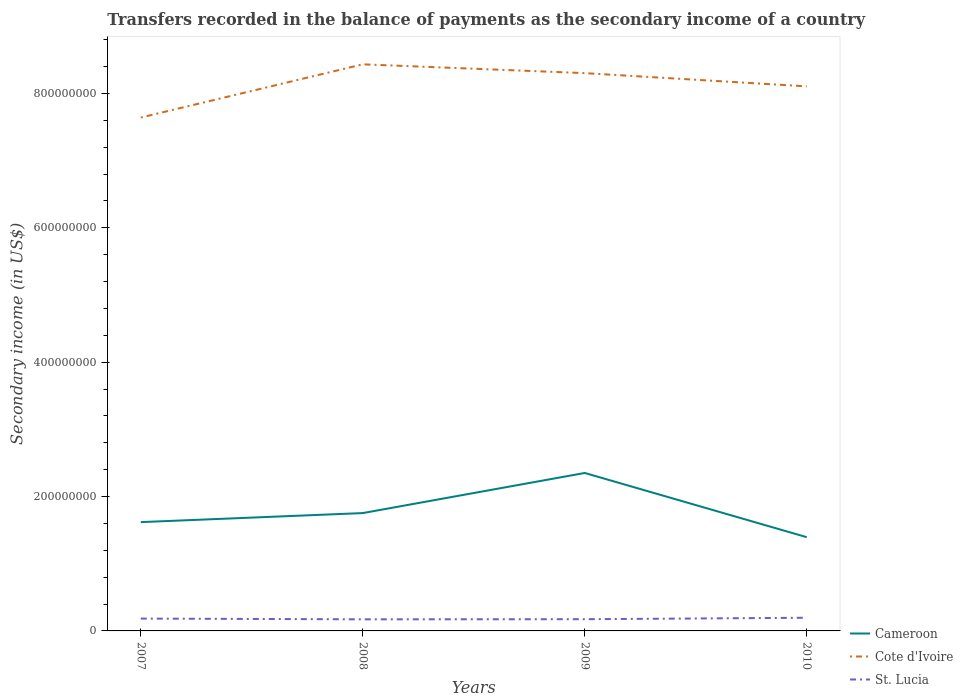Does the line corresponding to Cameroon intersect with the line corresponding to St. Lucia?
Provide a succinct answer. No. Is the number of lines equal to the number of legend labels?
Keep it short and to the point. Yes. Across all years, what is the maximum secondary income of in Cote d'Ivoire?
Your answer should be very brief. 7.64e+08. In which year was the secondary income of in Cote d'Ivoire maximum?
Your answer should be compact. 2007. What is the total secondary income of in St. Lucia in the graph?
Keep it short and to the point. -1.74e+05. What is the difference between the highest and the second highest secondary income of in Cameroon?
Your response must be concise. 9.56e+07. What is the difference between the highest and the lowest secondary income of in Cameroon?
Make the answer very short. 1. What is the difference between two consecutive major ticks on the Y-axis?
Offer a very short reply. 2.00e+08. Are the values on the major ticks of Y-axis written in scientific E-notation?
Make the answer very short. No. Where does the legend appear in the graph?
Your answer should be very brief. Bottom right. How many legend labels are there?
Your response must be concise. 3. How are the legend labels stacked?
Provide a succinct answer. Vertical. What is the title of the graph?
Provide a succinct answer. Transfers recorded in the balance of payments as the secondary income of a country. Does "High income" appear as one of the legend labels in the graph?
Provide a short and direct response. No. What is the label or title of the Y-axis?
Your answer should be very brief. Secondary income (in US$). What is the Secondary income (in US$) in Cameroon in 2007?
Your response must be concise. 1.62e+08. What is the Secondary income (in US$) in Cote d'Ivoire in 2007?
Your answer should be compact. 7.64e+08. What is the Secondary income (in US$) in St. Lucia in 2007?
Your answer should be very brief. 1.84e+07. What is the Secondary income (in US$) in Cameroon in 2008?
Give a very brief answer. 1.75e+08. What is the Secondary income (in US$) of Cote d'Ivoire in 2008?
Ensure brevity in your answer.  8.43e+08. What is the Secondary income (in US$) in St. Lucia in 2008?
Offer a terse response. 1.73e+07. What is the Secondary income (in US$) of Cameroon in 2009?
Your answer should be very brief. 2.35e+08. What is the Secondary income (in US$) of Cote d'Ivoire in 2009?
Ensure brevity in your answer.  8.30e+08. What is the Secondary income (in US$) in St. Lucia in 2009?
Give a very brief answer. 1.74e+07. What is the Secondary income (in US$) of Cameroon in 2010?
Make the answer very short. 1.40e+08. What is the Secondary income (in US$) in Cote d'Ivoire in 2010?
Provide a succinct answer. 8.11e+08. What is the Secondary income (in US$) of St. Lucia in 2010?
Keep it short and to the point. 1.96e+07. Across all years, what is the maximum Secondary income (in US$) of Cameroon?
Make the answer very short. 2.35e+08. Across all years, what is the maximum Secondary income (in US$) of Cote d'Ivoire?
Offer a very short reply. 8.43e+08. Across all years, what is the maximum Secondary income (in US$) in St. Lucia?
Your answer should be compact. 1.96e+07. Across all years, what is the minimum Secondary income (in US$) in Cameroon?
Provide a short and direct response. 1.40e+08. Across all years, what is the minimum Secondary income (in US$) of Cote d'Ivoire?
Provide a succinct answer. 7.64e+08. Across all years, what is the minimum Secondary income (in US$) of St. Lucia?
Ensure brevity in your answer.  1.73e+07. What is the total Secondary income (in US$) in Cameroon in the graph?
Provide a short and direct response. 7.12e+08. What is the total Secondary income (in US$) of Cote d'Ivoire in the graph?
Give a very brief answer. 3.25e+09. What is the total Secondary income (in US$) of St. Lucia in the graph?
Provide a succinct answer. 7.27e+07. What is the difference between the Secondary income (in US$) in Cameroon in 2007 and that in 2008?
Provide a short and direct response. -1.34e+07. What is the difference between the Secondary income (in US$) of Cote d'Ivoire in 2007 and that in 2008?
Your answer should be very brief. -7.92e+07. What is the difference between the Secondary income (in US$) in St. Lucia in 2007 and that in 2008?
Keep it short and to the point. 1.11e+06. What is the difference between the Secondary income (in US$) in Cameroon in 2007 and that in 2009?
Your answer should be very brief. -7.31e+07. What is the difference between the Secondary income (in US$) of Cote d'Ivoire in 2007 and that in 2009?
Give a very brief answer. -6.61e+07. What is the difference between the Secondary income (in US$) of St. Lucia in 2007 and that in 2009?
Provide a short and direct response. 9.37e+05. What is the difference between the Secondary income (in US$) of Cameroon in 2007 and that in 2010?
Your answer should be compact. 2.24e+07. What is the difference between the Secondary income (in US$) in Cote d'Ivoire in 2007 and that in 2010?
Your answer should be compact. -4.64e+07. What is the difference between the Secondary income (in US$) of St. Lucia in 2007 and that in 2010?
Give a very brief answer. -1.23e+06. What is the difference between the Secondary income (in US$) in Cameroon in 2008 and that in 2009?
Keep it short and to the point. -5.97e+07. What is the difference between the Secondary income (in US$) in Cote d'Ivoire in 2008 and that in 2009?
Your answer should be very brief. 1.31e+07. What is the difference between the Secondary income (in US$) in St. Lucia in 2008 and that in 2009?
Your response must be concise. -1.74e+05. What is the difference between the Secondary income (in US$) of Cameroon in 2008 and that in 2010?
Give a very brief answer. 3.59e+07. What is the difference between the Secondary income (in US$) of Cote d'Ivoire in 2008 and that in 2010?
Keep it short and to the point. 3.28e+07. What is the difference between the Secondary income (in US$) of St. Lucia in 2008 and that in 2010?
Give a very brief answer. -2.34e+06. What is the difference between the Secondary income (in US$) in Cameroon in 2009 and that in 2010?
Give a very brief answer. 9.56e+07. What is the difference between the Secondary income (in US$) in Cote d'Ivoire in 2009 and that in 2010?
Offer a very short reply. 1.97e+07. What is the difference between the Secondary income (in US$) of St. Lucia in 2009 and that in 2010?
Offer a very short reply. -2.16e+06. What is the difference between the Secondary income (in US$) of Cameroon in 2007 and the Secondary income (in US$) of Cote d'Ivoire in 2008?
Make the answer very short. -6.81e+08. What is the difference between the Secondary income (in US$) of Cameroon in 2007 and the Secondary income (in US$) of St. Lucia in 2008?
Make the answer very short. 1.45e+08. What is the difference between the Secondary income (in US$) in Cote d'Ivoire in 2007 and the Secondary income (in US$) in St. Lucia in 2008?
Give a very brief answer. 7.47e+08. What is the difference between the Secondary income (in US$) in Cameroon in 2007 and the Secondary income (in US$) in Cote d'Ivoire in 2009?
Provide a short and direct response. -6.68e+08. What is the difference between the Secondary income (in US$) in Cameroon in 2007 and the Secondary income (in US$) in St. Lucia in 2009?
Keep it short and to the point. 1.45e+08. What is the difference between the Secondary income (in US$) in Cote d'Ivoire in 2007 and the Secondary income (in US$) in St. Lucia in 2009?
Make the answer very short. 7.47e+08. What is the difference between the Secondary income (in US$) of Cameroon in 2007 and the Secondary income (in US$) of Cote d'Ivoire in 2010?
Your response must be concise. -6.49e+08. What is the difference between the Secondary income (in US$) of Cameroon in 2007 and the Secondary income (in US$) of St. Lucia in 2010?
Offer a very short reply. 1.42e+08. What is the difference between the Secondary income (in US$) in Cote d'Ivoire in 2007 and the Secondary income (in US$) in St. Lucia in 2010?
Your answer should be compact. 7.45e+08. What is the difference between the Secondary income (in US$) of Cameroon in 2008 and the Secondary income (in US$) of Cote d'Ivoire in 2009?
Your answer should be compact. -6.55e+08. What is the difference between the Secondary income (in US$) of Cameroon in 2008 and the Secondary income (in US$) of St. Lucia in 2009?
Provide a short and direct response. 1.58e+08. What is the difference between the Secondary income (in US$) in Cote d'Ivoire in 2008 and the Secondary income (in US$) in St. Lucia in 2009?
Your answer should be very brief. 8.26e+08. What is the difference between the Secondary income (in US$) in Cameroon in 2008 and the Secondary income (in US$) in Cote d'Ivoire in 2010?
Offer a terse response. -6.35e+08. What is the difference between the Secondary income (in US$) of Cameroon in 2008 and the Secondary income (in US$) of St. Lucia in 2010?
Offer a terse response. 1.56e+08. What is the difference between the Secondary income (in US$) of Cote d'Ivoire in 2008 and the Secondary income (in US$) of St. Lucia in 2010?
Make the answer very short. 8.24e+08. What is the difference between the Secondary income (in US$) of Cameroon in 2009 and the Secondary income (in US$) of Cote d'Ivoire in 2010?
Keep it short and to the point. -5.75e+08. What is the difference between the Secondary income (in US$) of Cameroon in 2009 and the Secondary income (in US$) of St. Lucia in 2010?
Your answer should be compact. 2.16e+08. What is the difference between the Secondary income (in US$) in Cote d'Ivoire in 2009 and the Secondary income (in US$) in St. Lucia in 2010?
Keep it short and to the point. 8.11e+08. What is the average Secondary income (in US$) of Cameroon per year?
Provide a short and direct response. 1.78e+08. What is the average Secondary income (in US$) in Cote d'Ivoire per year?
Offer a very short reply. 8.12e+08. What is the average Secondary income (in US$) in St. Lucia per year?
Give a very brief answer. 1.82e+07. In the year 2007, what is the difference between the Secondary income (in US$) of Cameroon and Secondary income (in US$) of Cote d'Ivoire?
Make the answer very short. -6.02e+08. In the year 2007, what is the difference between the Secondary income (in US$) in Cameroon and Secondary income (in US$) in St. Lucia?
Your answer should be compact. 1.44e+08. In the year 2007, what is the difference between the Secondary income (in US$) in Cote d'Ivoire and Secondary income (in US$) in St. Lucia?
Provide a succinct answer. 7.46e+08. In the year 2008, what is the difference between the Secondary income (in US$) of Cameroon and Secondary income (in US$) of Cote d'Ivoire?
Offer a terse response. -6.68e+08. In the year 2008, what is the difference between the Secondary income (in US$) of Cameroon and Secondary income (in US$) of St. Lucia?
Your answer should be compact. 1.58e+08. In the year 2008, what is the difference between the Secondary income (in US$) in Cote d'Ivoire and Secondary income (in US$) in St. Lucia?
Provide a succinct answer. 8.26e+08. In the year 2009, what is the difference between the Secondary income (in US$) of Cameroon and Secondary income (in US$) of Cote d'Ivoire?
Your answer should be very brief. -5.95e+08. In the year 2009, what is the difference between the Secondary income (in US$) of Cameroon and Secondary income (in US$) of St. Lucia?
Offer a terse response. 2.18e+08. In the year 2009, what is the difference between the Secondary income (in US$) of Cote d'Ivoire and Secondary income (in US$) of St. Lucia?
Ensure brevity in your answer.  8.13e+08. In the year 2010, what is the difference between the Secondary income (in US$) in Cameroon and Secondary income (in US$) in Cote d'Ivoire?
Keep it short and to the point. -6.71e+08. In the year 2010, what is the difference between the Secondary income (in US$) of Cameroon and Secondary income (in US$) of St. Lucia?
Your response must be concise. 1.20e+08. In the year 2010, what is the difference between the Secondary income (in US$) in Cote d'Ivoire and Secondary income (in US$) in St. Lucia?
Ensure brevity in your answer.  7.91e+08. What is the ratio of the Secondary income (in US$) in Cameroon in 2007 to that in 2008?
Offer a very short reply. 0.92. What is the ratio of the Secondary income (in US$) of Cote d'Ivoire in 2007 to that in 2008?
Ensure brevity in your answer.  0.91. What is the ratio of the Secondary income (in US$) of St. Lucia in 2007 to that in 2008?
Make the answer very short. 1.06. What is the ratio of the Secondary income (in US$) of Cameroon in 2007 to that in 2009?
Your answer should be very brief. 0.69. What is the ratio of the Secondary income (in US$) of Cote d'Ivoire in 2007 to that in 2009?
Provide a succinct answer. 0.92. What is the ratio of the Secondary income (in US$) in St. Lucia in 2007 to that in 2009?
Provide a succinct answer. 1.05. What is the ratio of the Secondary income (in US$) in Cameroon in 2007 to that in 2010?
Give a very brief answer. 1.16. What is the ratio of the Secondary income (in US$) in Cote d'Ivoire in 2007 to that in 2010?
Provide a succinct answer. 0.94. What is the ratio of the Secondary income (in US$) in St. Lucia in 2007 to that in 2010?
Make the answer very short. 0.94. What is the ratio of the Secondary income (in US$) in Cameroon in 2008 to that in 2009?
Provide a succinct answer. 0.75. What is the ratio of the Secondary income (in US$) in Cote d'Ivoire in 2008 to that in 2009?
Your answer should be compact. 1.02. What is the ratio of the Secondary income (in US$) of Cameroon in 2008 to that in 2010?
Give a very brief answer. 1.26. What is the ratio of the Secondary income (in US$) of Cote d'Ivoire in 2008 to that in 2010?
Ensure brevity in your answer.  1.04. What is the ratio of the Secondary income (in US$) in St. Lucia in 2008 to that in 2010?
Offer a very short reply. 0.88. What is the ratio of the Secondary income (in US$) in Cameroon in 2009 to that in 2010?
Ensure brevity in your answer.  1.68. What is the ratio of the Secondary income (in US$) in Cote d'Ivoire in 2009 to that in 2010?
Offer a very short reply. 1.02. What is the ratio of the Secondary income (in US$) in St. Lucia in 2009 to that in 2010?
Your response must be concise. 0.89. What is the difference between the highest and the second highest Secondary income (in US$) of Cameroon?
Give a very brief answer. 5.97e+07. What is the difference between the highest and the second highest Secondary income (in US$) of Cote d'Ivoire?
Keep it short and to the point. 1.31e+07. What is the difference between the highest and the second highest Secondary income (in US$) in St. Lucia?
Offer a terse response. 1.23e+06. What is the difference between the highest and the lowest Secondary income (in US$) in Cameroon?
Offer a terse response. 9.56e+07. What is the difference between the highest and the lowest Secondary income (in US$) in Cote d'Ivoire?
Ensure brevity in your answer.  7.92e+07. What is the difference between the highest and the lowest Secondary income (in US$) of St. Lucia?
Your response must be concise. 2.34e+06. 